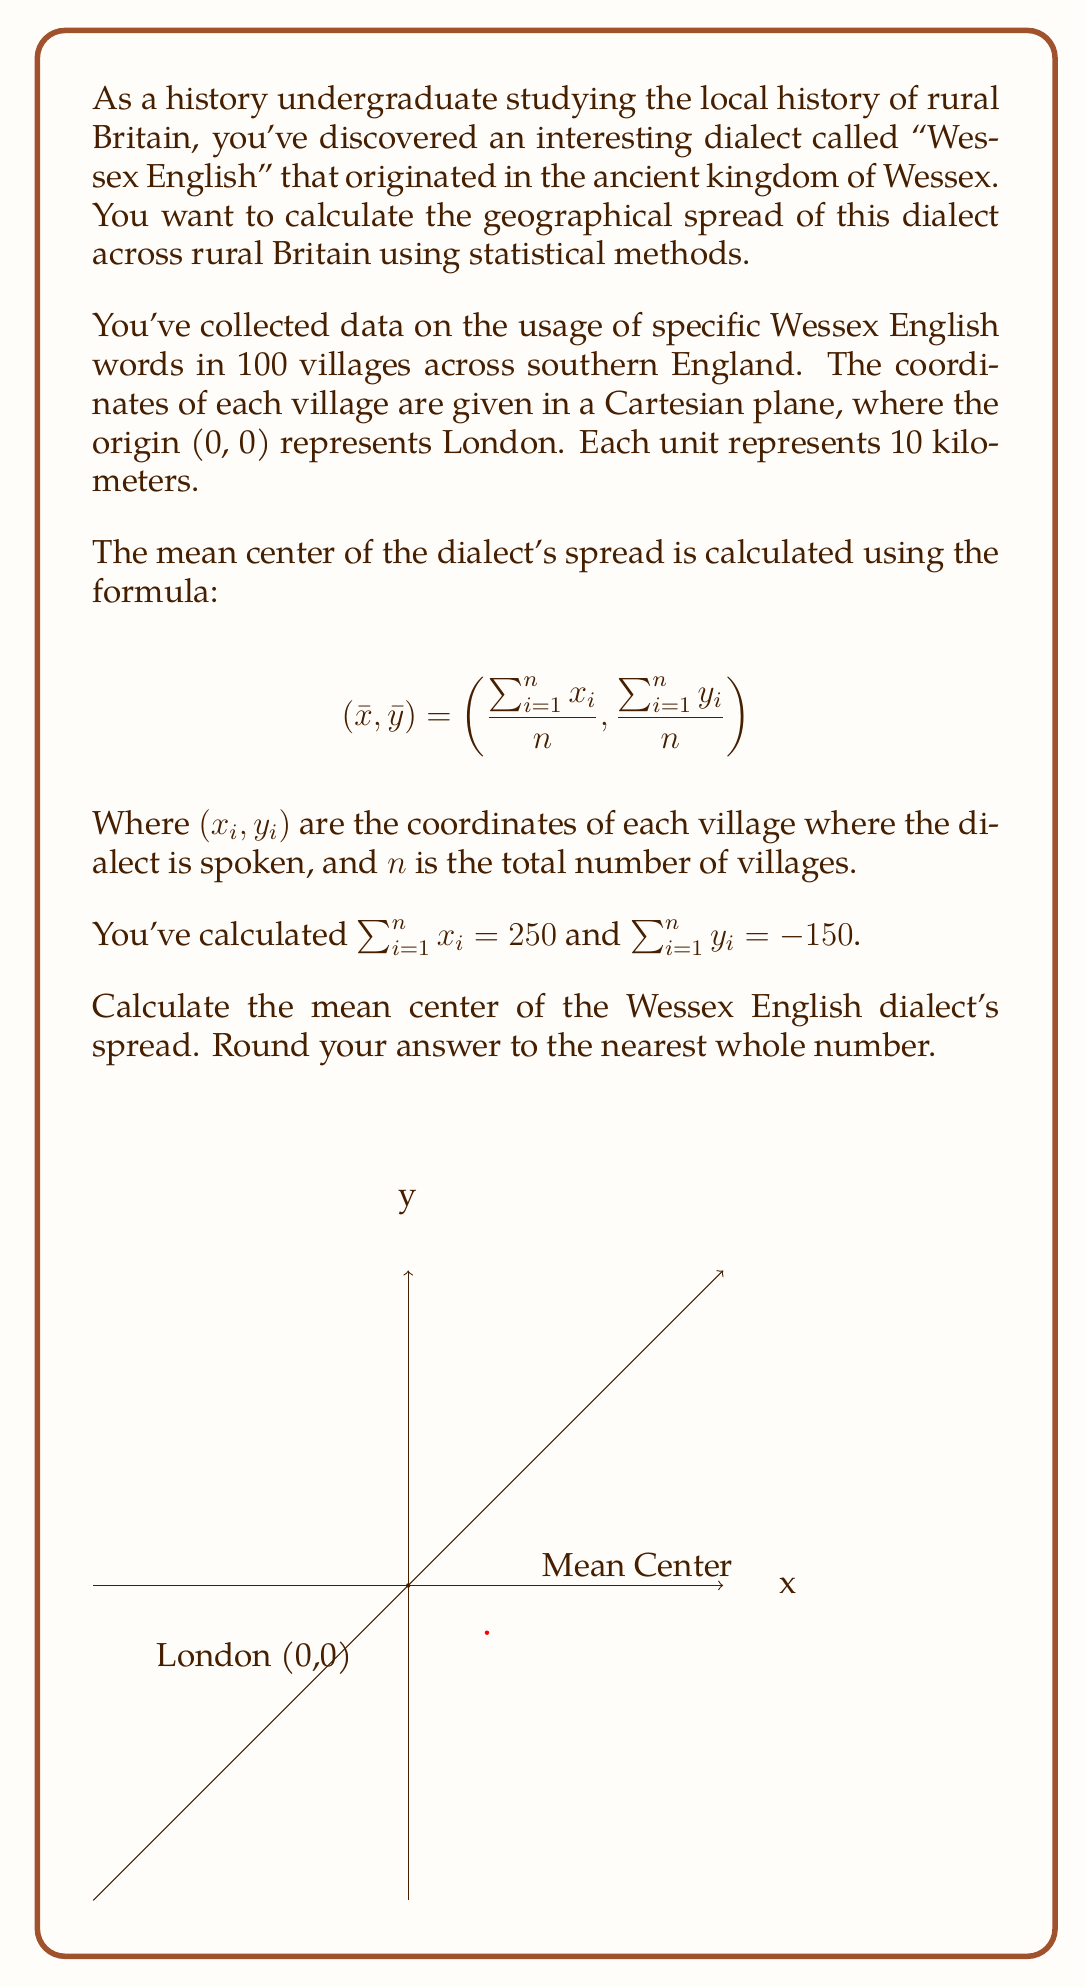Can you solve this math problem? Let's approach this step-by-step:

1) We're given the formula for the mean center:
   $$(\bar{x}, \bar{y}) = (\frac{\sum_{i=1}^n x_i}{n}, \frac{\sum_{i=1}^n y_i}{n})$$

2) We're also given:
   $\sum_{i=1}^n x_i = 250$
   $\sum_{i=1}^n y_i = -150$
   $n = 100$ (total number of villages)

3) Let's calculate $\bar{x}$:
   $$\bar{x} = \frac{\sum_{i=1}^n x_i}{n} = \frac{250}{100} = 2.5$$

4) Now, let's calculate $\bar{y}$:
   $$\bar{y} = \frac{\sum_{i=1}^n y_i}{n} = \frac{-150}{100} = -1.5$$

5) Therefore, the mean center is at (2.5, -1.5).

6) Remember, each unit represents 10 kilometers. So:
   - 2.5 units east is 25 km east of London
   - 1.5 units south is 15 km south of London

7) Rounding to the nearest whole number:
   (2.5, -1.5) ≈ (3, -2)

This means the mean center of the Wessex English dialect's spread is approximately 30 km east and 20 km south of London.
Answer: (3, -2) 